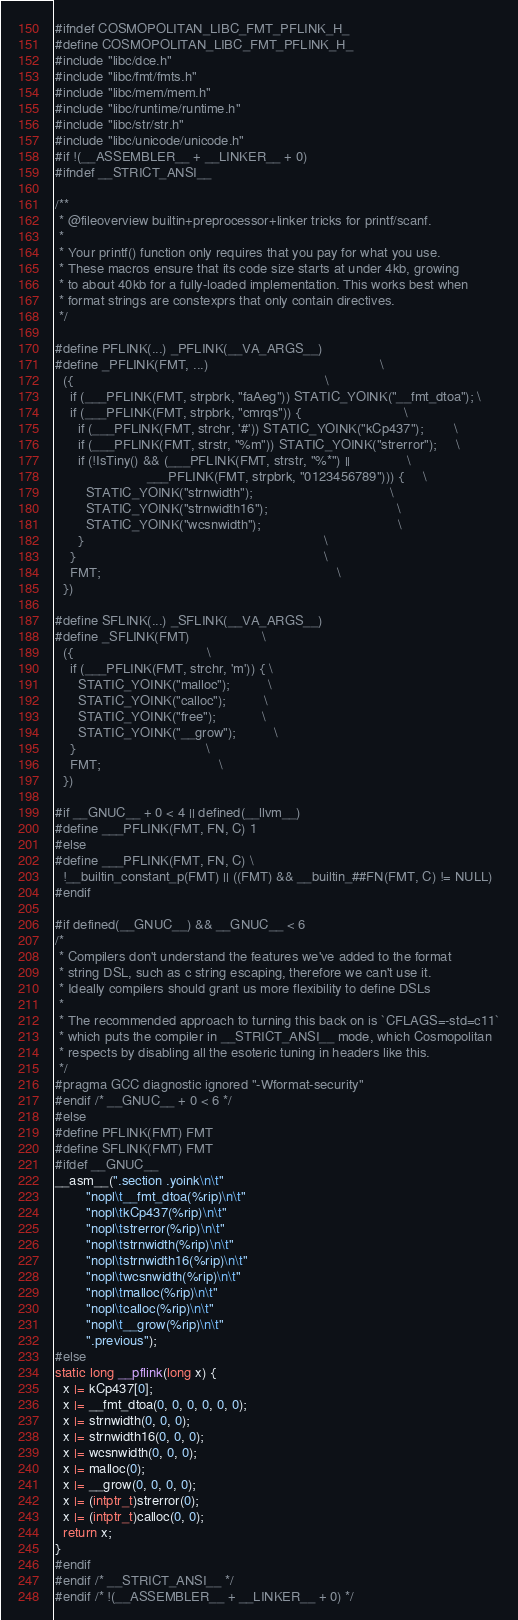Convert code to text. <code><loc_0><loc_0><loc_500><loc_500><_C_>#ifndef COSMOPOLITAN_LIBC_FMT_PFLINK_H_
#define COSMOPOLITAN_LIBC_FMT_PFLINK_H_
#include "libc/dce.h"
#include "libc/fmt/fmts.h"
#include "libc/mem/mem.h"
#include "libc/runtime/runtime.h"
#include "libc/str/str.h"
#include "libc/unicode/unicode.h"
#if !(__ASSEMBLER__ + __LINKER__ + 0)
#ifndef __STRICT_ANSI__

/**
 * @fileoverview builtin+preprocessor+linker tricks for printf/scanf.
 *
 * Your printf() function only requires that you pay for what you use.
 * These macros ensure that its code size starts at under 4kb, growing
 * to about 40kb for a fully-loaded implementation. This works best when
 * format strings are constexprs that only contain directives.
 */

#define PFLINK(...) _PFLINK(__VA_ARGS__)
#define _PFLINK(FMT, ...)                                             \
  ({                                                                  \
    if (___PFLINK(FMT, strpbrk, "faAeg")) STATIC_YOINK("__fmt_dtoa"); \
    if (___PFLINK(FMT, strpbrk, "cmrqs")) {                           \
      if (___PFLINK(FMT, strchr, '#')) STATIC_YOINK("kCp437");        \
      if (___PFLINK(FMT, strstr, "%m")) STATIC_YOINK("strerror");     \
      if (!IsTiny() && (___PFLINK(FMT, strstr, "%*") ||               \
                        ___PFLINK(FMT, strpbrk, "0123456789"))) {     \
        STATIC_YOINK("strnwidth");                                    \
        STATIC_YOINK("strnwidth16");                                  \
        STATIC_YOINK("wcsnwidth");                                    \
      }                                                               \
    }                                                                 \
    FMT;                                                              \
  })

#define SFLINK(...) _SFLINK(__VA_ARGS__)
#define _SFLINK(FMT)                   \
  ({                                   \
    if (___PFLINK(FMT, strchr, 'm')) { \
      STATIC_YOINK("malloc");          \
      STATIC_YOINK("calloc");          \
      STATIC_YOINK("free");            \
      STATIC_YOINK("__grow");          \
    }                                  \
    FMT;                               \
  })

#if __GNUC__ + 0 < 4 || defined(__llvm__)
#define ___PFLINK(FMT, FN, C) 1
#else
#define ___PFLINK(FMT, FN, C) \
  !__builtin_constant_p(FMT) || ((FMT) && __builtin_##FN(FMT, C) != NULL)
#endif

#if defined(__GNUC__) && __GNUC__ < 6
/*
 * Compilers don't understand the features we've added to the format
 * string DSL, such as c string escaping, therefore we can't use it.
 * Ideally compilers should grant us more flexibility to define DSLs
 *
 * The recommended approach to turning this back on is `CFLAGS=-std=c11`
 * which puts the compiler in __STRICT_ANSI__ mode, which Cosmopolitan
 * respects by disabling all the esoteric tuning in headers like this.
 */
#pragma GCC diagnostic ignored "-Wformat-security"
#endif /* __GNUC__ + 0 < 6 */
#else
#define PFLINK(FMT) FMT
#define SFLINK(FMT) FMT
#ifdef __GNUC__
__asm__(".section .yoink\n\t"
        "nopl\t__fmt_dtoa(%rip)\n\t"
        "nopl\tkCp437(%rip)\n\t"
        "nopl\tstrerror(%rip)\n\t"
        "nopl\tstrnwidth(%rip)\n\t"
        "nopl\tstrnwidth16(%rip)\n\t"
        "nopl\twcsnwidth(%rip)\n\t"
        "nopl\tmalloc(%rip)\n\t"
        "nopl\tcalloc(%rip)\n\t"
        "nopl\t__grow(%rip)\n\t"
        ".previous");
#else
static long __pflink(long x) {
  x |= kCp437[0];
  x |= __fmt_dtoa(0, 0, 0, 0, 0, 0);
  x |= strnwidth(0, 0, 0);
  x |= strnwidth16(0, 0, 0);
  x |= wcsnwidth(0, 0, 0);
  x |= malloc(0);
  x |= __grow(0, 0, 0, 0);
  x |= (intptr_t)strerror(0);
  x |= (intptr_t)calloc(0, 0);
  return x;
}
#endif
#endif /* __STRICT_ANSI__ */
#endif /* !(__ASSEMBLER__ + __LINKER__ + 0) */</code> 